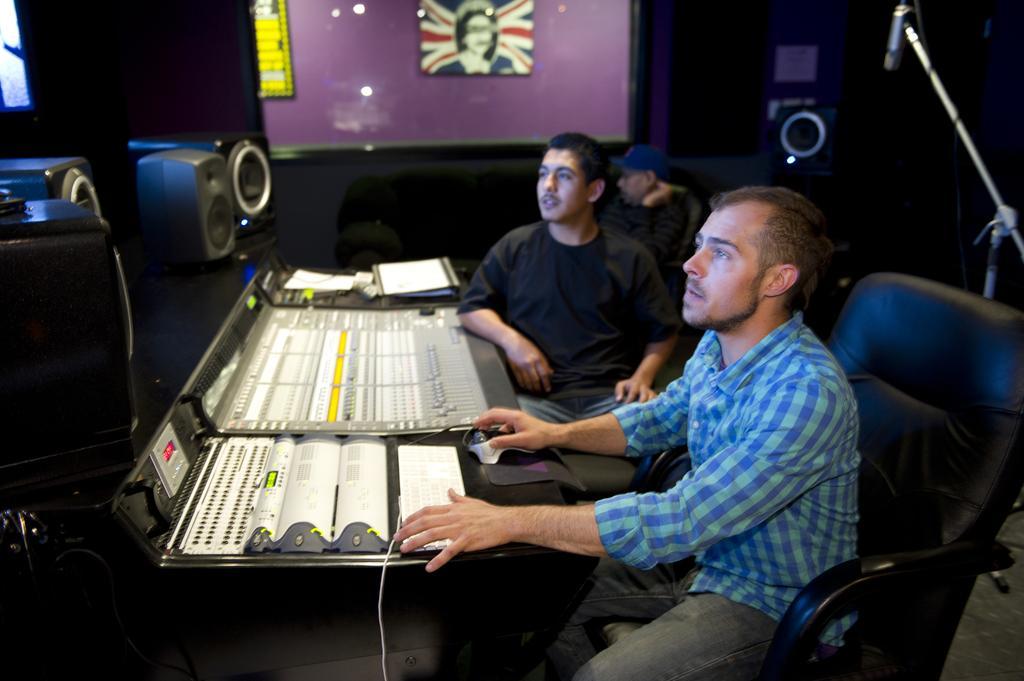How would you summarize this image in a sentence or two? In this image i can see two men sitting on a chair a man at the front wearing blue shirt and jeans, at back he is wearing black shirt and jeans, there is some musical instrument in front of them at the back ground i can, see the other person sitting on a couch ,a board attached to a glass wall at left there are, at right there is a micro phone. 